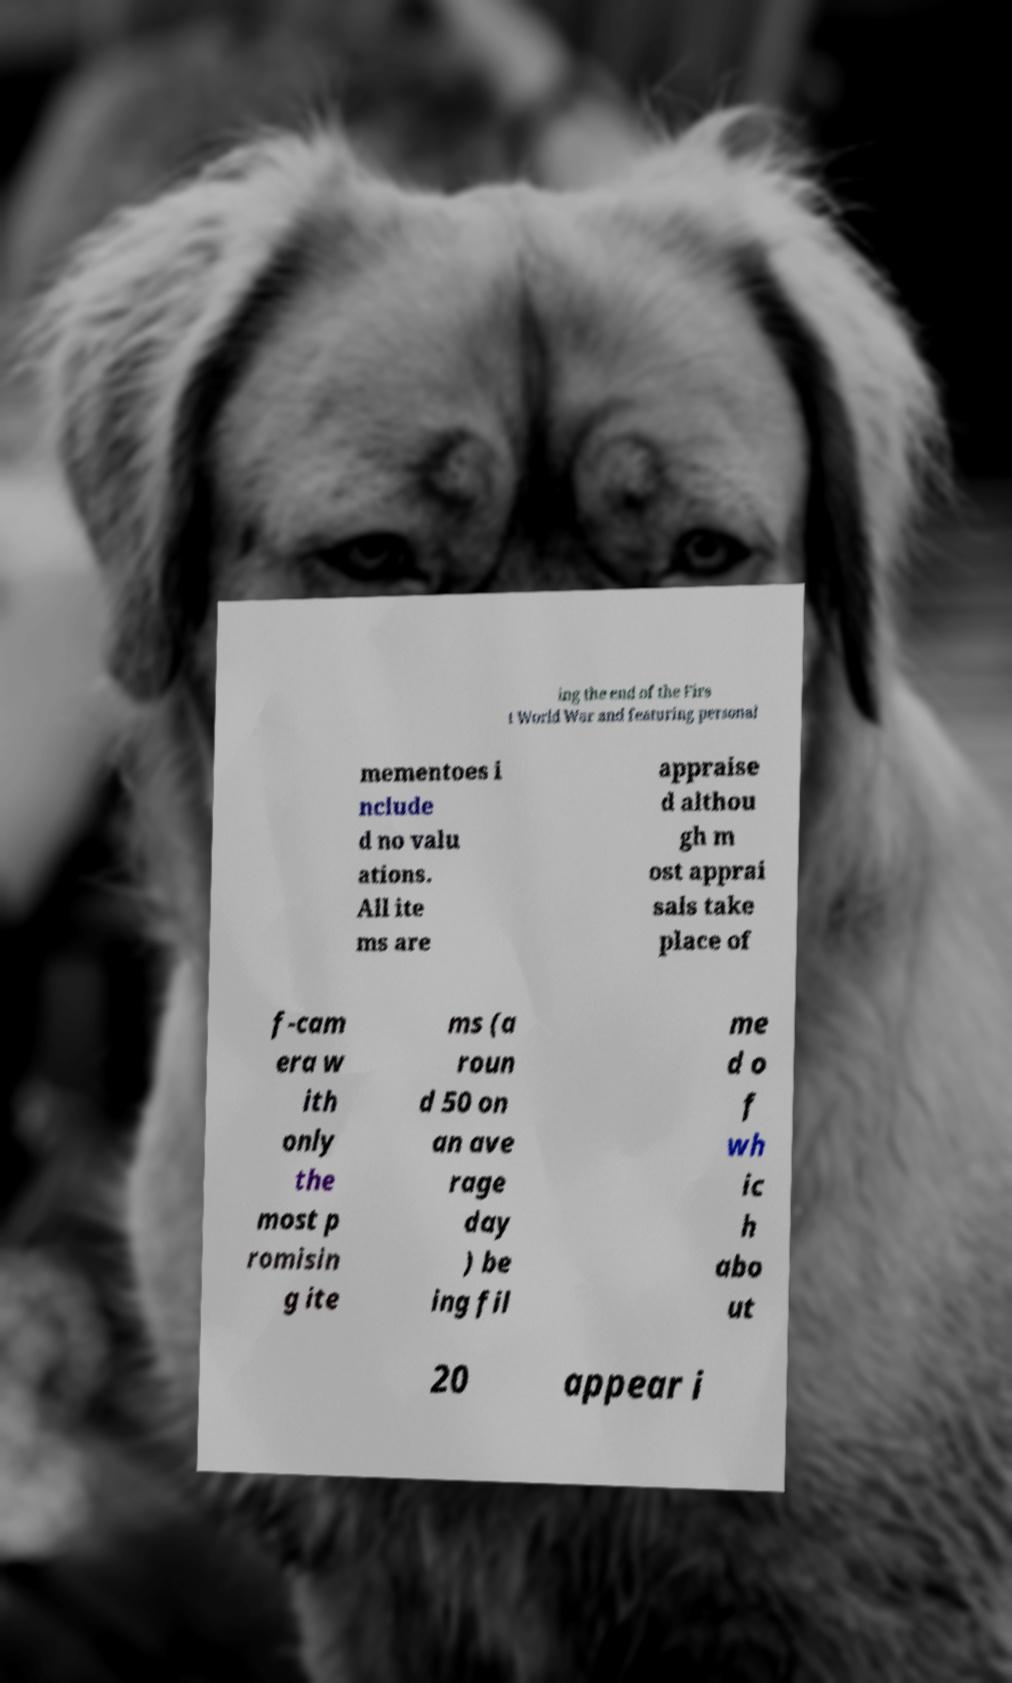Please identify and transcribe the text found in this image. ing the end of the Firs t World War and featuring personal mementoes i nclude d no valu ations. All ite ms are appraise d althou gh m ost apprai sals take place of f-cam era w ith only the most p romisin g ite ms (a roun d 50 on an ave rage day ) be ing fil me d o f wh ic h abo ut 20 appear i 